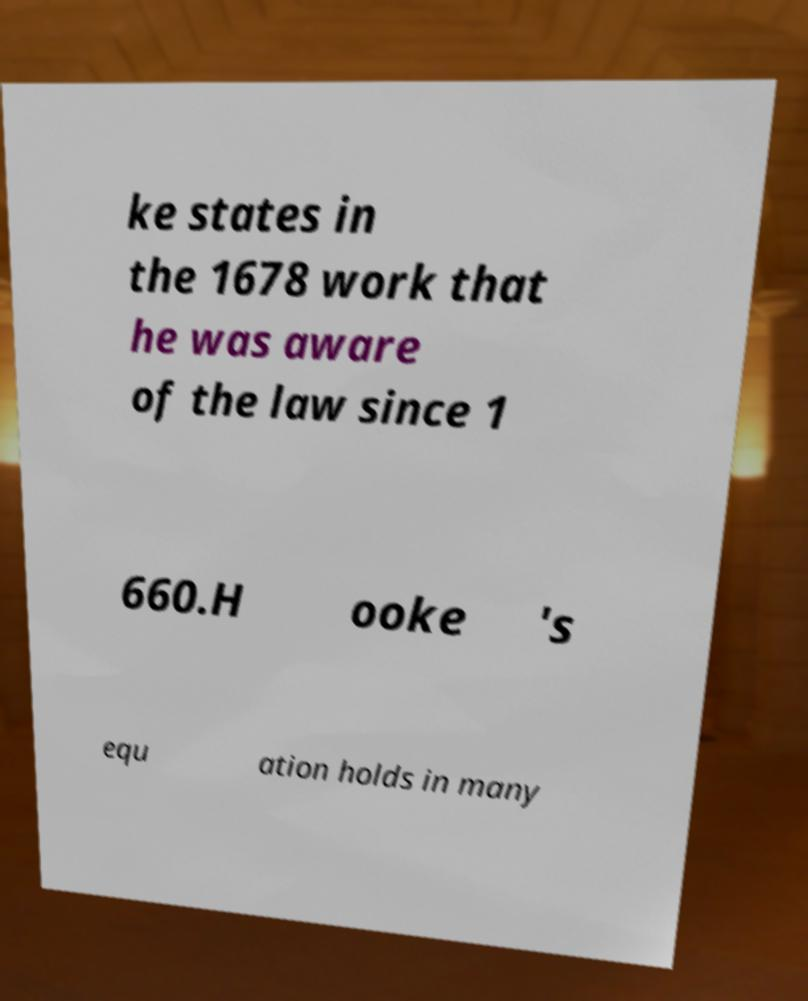Could you extract and type out the text from this image? ke states in the 1678 work that he was aware of the law since 1 660.H ooke 's equ ation holds in many 